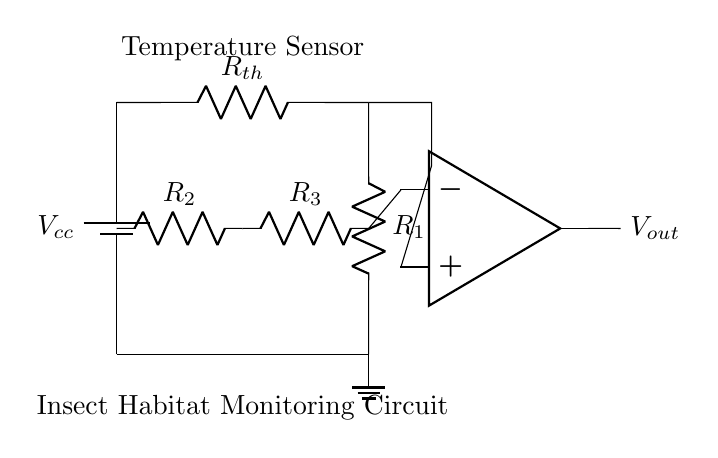What type of sensor is used in this circuit? The circuit includes a thermistor, which is a type of temperature sensor that changes its resistance with temperature variations.
Answer: thermistor What is the purpose of the op-amp in the circuit? The op-amp compares the voltage from the thermistor and the voltage from the reference resistor network, amplifying any difference to produce a measurable output voltage.
Answer: amplification What does the output voltage represent? The output voltage, denoted as V out, corresponds to the temperature measured by the thermistor after processing by the op-amp, indicating the current temperature.
Answer: temperature What is the configuration of resistors R2 and R3? Resistors R2 and R3 are arranged in a voltage divider configuration to set a reference voltage for the non-inverting input of the op-amp, typically for comparison purposes.
Answer: voltage divider How many resistors are present in the circuit? The circuit includes three resistors: the thermistor R th and two additional resistors R1 and R2, contributing to the voltage divider and temperature sensing functionality.
Answer: three What is the function of R1 in the circuit? Resistor R1 forms part of the voltage divider with the thermistor, determining the output voltage based on the thermistor's resistance change due to temperature fluctuations.
Answer: voltage divider 